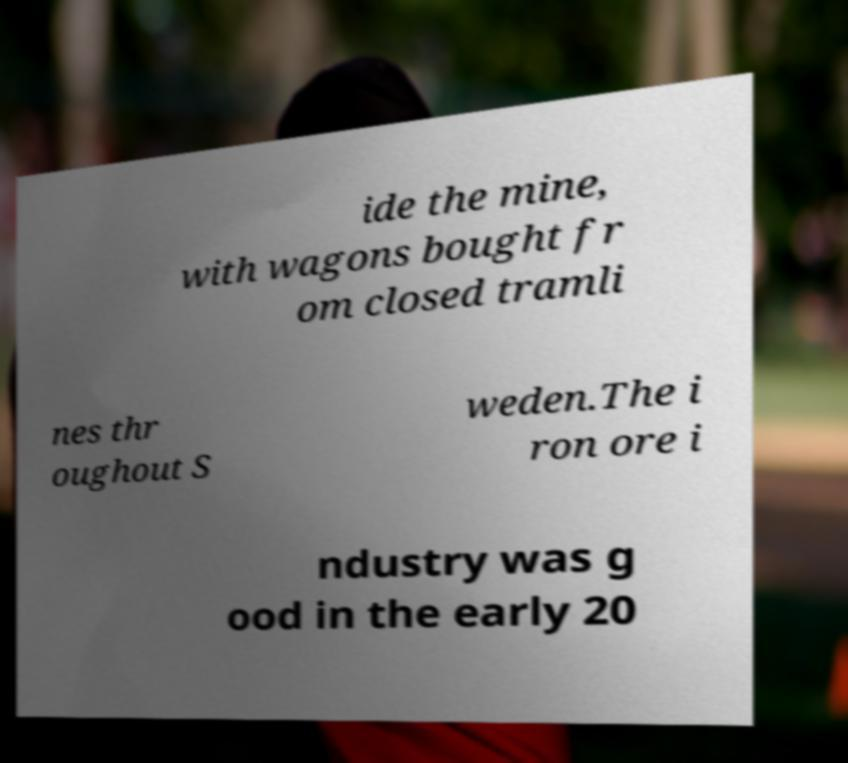There's text embedded in this image that I need extracted. Can you transcribe it verbatim? ide the mine, with wagons bought fr om closed tramli nes thr oughout S weden.The i ron ore i ndustry was g ood in the early 20 